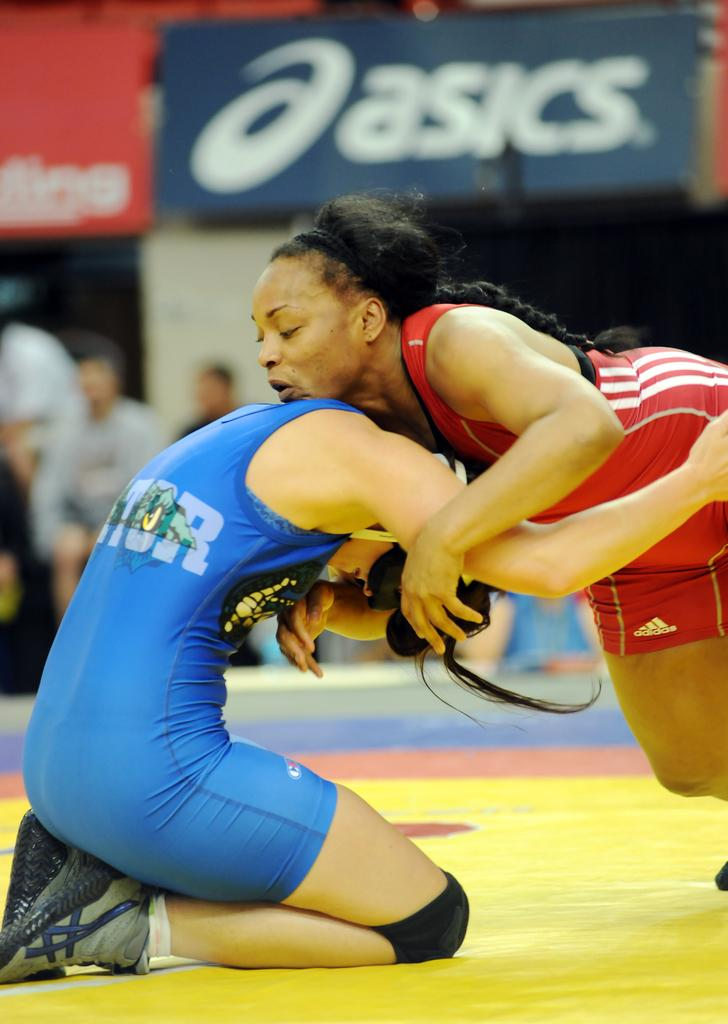<image>
Share a concise interpretation of the image provided. women wrestling on the ground mat beneath an ASICS ad 